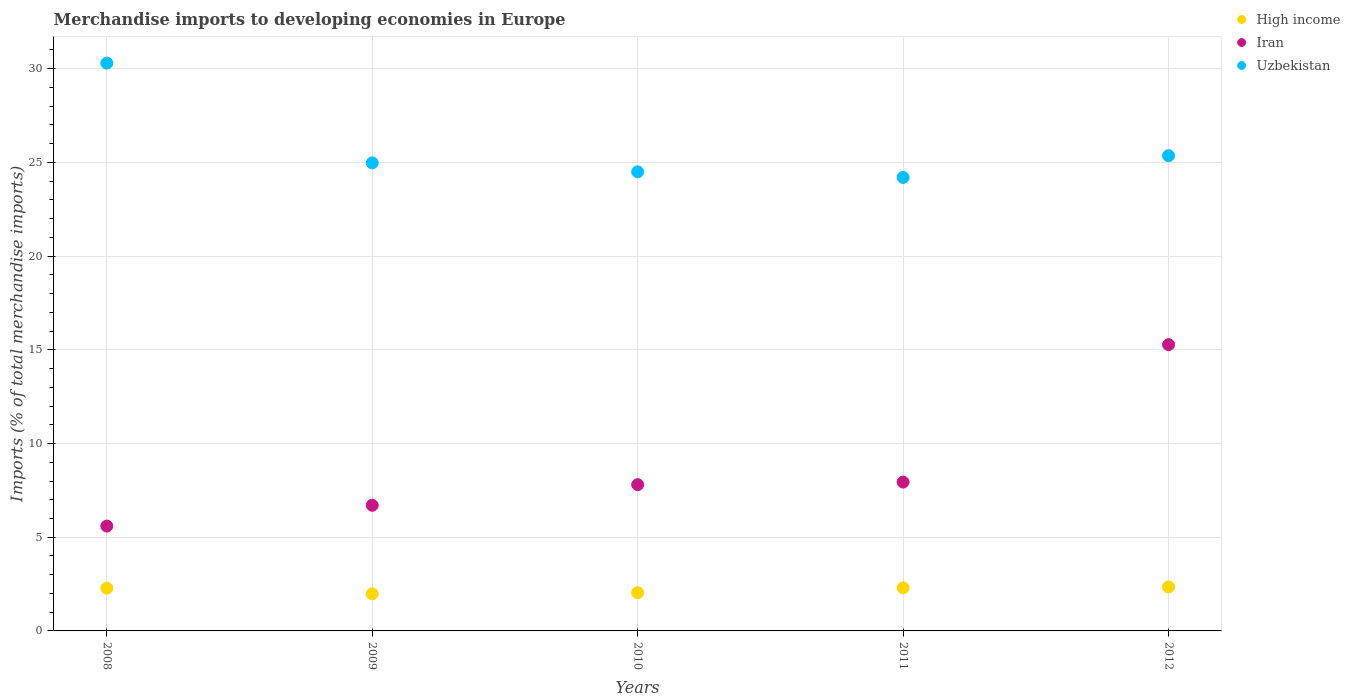How many different coloured dotlines are there?
Provide a short and direct response. 3. Is the number of dotlines equal to the number of legend labels?
Provide a succinct answer. Yes. What is the percentage total merchandise imports in Iran in 2008?
Provide a succinct answer. 5.6. Across all years, what is the maximum percentage total merchandise imports in Uzbekistan?
Provide a succinct answer. 30.3. Across all years, what is the minimum percentage total merchandise imports in Iran?
Provide a short and direct response. 5.6. In which year was the percentage total merchandise imports in Iran maximum?
Ensure brevity in your answer.  2012. What is the total percentage total merchandise imports in Iran in the graph?
Your response must be concise. 43.32. What is the difference between the percentage total merchandise imports in Iran in 2009 and that in 2010?
Ensure brevity in your answer.  -1.1. What is the difference between the percentage total merchandise imports in High income in 2012 and the percentage total merchandise imports in Uzbekistan in 2008?
Provide a short and direct response. -27.95. What is the average percentage total merchandise imports in Iran per year?
Your response must be concise. 8.66. In the year 2009, what is the difference between the percentage total merchandise imports in Iran and percentage total merchandise imports in High income?
Ensure brevity in your answer.  4.72. In how many years, is the percentage total merchandise imports in Iran greater than 8 %?
Keep it short and to the point. 1. What is the ratio of the percentage total merchandise imports in Uzbekistan in 2008 to that in 2010?
Make the answer very short. 1.24. Is the difference between the percentage total merchandise imports in Iran in 2008 and 2012 greater than the difference between the percentage total merchandise imports in High income in 2008 and 2012?
Your answer should be very brief. No. What is the difference between the highest and the second highest percentage total merchandise imports in Iran?
Your answer should be very brief. 7.33. What is the difference between the highest and the lowest percentage total merchandise imports in Uzbekistan?
Give a very brief answer. 6.1. In how many years, is the percentage total merchandise imports in Iran greater than the average percentage total merchandise imports in Iran taken over all years?
Offer a very short reply. 1. Is the percentage total merchandise imports in Uzbekistan strictly greater than the percentage total merchandise imports in Iran over the years?
Provide a short and direct response. Yes. Is the percentage total merchandise imports in Iran strictly less than the percentage total merchandise imports in High income over the years?
Make the answer very short. No. How many dotlines are there?
Provide a succinct answer. 3. How many years are there in the graph?
Give a very brief answer. 5. What is the difference between two consecutive major ticks on the Y-axis?
Your response must be concise. 5. What is the title of the graph?
Offer a terse response. Merchandise imports to developing economies in Europe. What is the label or title of the Y-axis?
Ensure brevity in your answer.  Imports (% of total merchandise imports). What is the Imports (% of total merchandise imports) in High income in 2008?
Offer a terse response. 2.28. What is the Imports (% of total merchandise imports) of Iran in 2008?
Keep it short and to the point. 5.6. What is the Imports (% of total merchandise imports) of Uzbekistan in 2008?
Offer a terse response. 30.3. What is the Imports (% of total merchandise imports) of High income in 2009?
Offer a very short reply. 1.98. What is the Imports (% of total merchandise imports) in Iran in 2009?
Offer a very short reply. 6.7. What is the Imports (% of total merchandise imports) of Uzbekistan in 2009?
Keep it short and to the point. 24.98. What is the Imports (% of total merchandise imports) of High income in 2010?
Your answer should be very brief. 2.04. What is the Imports (% of total merchandise imports) in Iran in 2010?
Offer a very short reply. 7.81. What is the Imports (% of total merchandise imports) in Uzbekistan in 2010?
Offer a very short reply. 24.5. What is the Imports (% of total merchandise imports) of High income in 2011?
Your answer should be compact. 2.3. What is the Imports (% of total merchandise imports) of Iran in 2011?
Give a very brief answer. 7.94. What is the Imports (% of total merchandise imports) in Uzbekistan in 2011?
Provide a succinct answer. 24.2. What is the Imports (% of total merchandise imports) in High income in 2012?
Your answer should be compact. 2.35. What is the Imports (% of total merchandise imports) in Iran in 2012?
Provide a succinct answer. 15.28. What is the Imports (% of total merchandise imports) of Uzbekistan in 2012?
Provide a short and direct response. 25.36. Across all years, what is the maximum Imports (% of total merchandise imports) in High income?
Provide a succinct answer. 2.35. Across all years, what is the maximum Imports (% of total merchandise imports) of Iran?
Offer a very short reply. 15.28. Across all years, what is the maximum Imports (% of total merchandise imports) of Uzbekistan?
Provide a succinct answer. 30.3. Across all years, what is the minimum Imports (% of total merchandise imports) of High income?
Make the answer very short. 1.98. Across all years, what is the minimum Imports (% of total merchandise imports) in Iran?
Provide a short and direct response. 5.6. Across all years, what is the minimum Imports (% of total merchandise imports) of Uzbekistan?
Ensure brevity in your answer.  24.2. What is the total Imports (% of total merchandise imports) of High income in the graph?
Keep it short and to the point. 10.95. What is the total Imports (% of total merchandise imports) in Iran in the graph?
Your answer should be very brief. 43.32. What is the total Imports (% of total merchandise imports) in Uzbekistan in the graph?
Your answer should be compact. 129.34. What is the difference between the Imports (% of total merchandise imports) of High income in 2008 and that in 2009?
Give a very brief answer. 0.3. What is the difference between the Imports (% of total merchandise imports) of Iran in 2008 and that in 2009?
Give a very brief answer. -1.11. What is the difference between the Imports (% of total merchandise imports) in Uzbekistan in 2008 and that in 2009?
Your answer should be very brief. 5.32. What is the difference between the Imports (% of total merchandise imports) of High income in 2008 and that in 2010?
Ensure brevity in your answer.  0.24. What is the difference between the Imports (% of total merchandise imports) in Iran in 2008 and that in 2010?
Offer a terse response. -2.21. What is the difference between the Imports (% of total merchandise imports) of Uzbekistan in 2008 and that in 2010?
Ensure brevity in your answer.  5.8. What is the difference between the Imports (% of total merchandise imports) of High income in 2008 and that in 2011?
Ensure brevity in your answer.  -0.02. What is the difference between the Imports (% of total merchandise imports) of Iran in 2008 and that in 2011?
Make the answer very short. -2.35. What is the difference between the Imports (% of total merchandise imports) of Uzbekistan in 2008 and that in 2011?
Your answer should be very brief. 6.1. What is the difference between the Imports (% of total merchandise imports) in High income in 2008 and that in 2012?
Offer a very short reply. -0.07. What is the difference between the Imports (% of total merchandise imports) of Iran in 2008 and that in 2012?
Give a very brief answer. -9.68. What is the difference between the Imports (% of total merchandise imports) of Uzbekistan in 2008 and that in 2012?
Offer a terse response. 4.94. What is the difference between the Imports (% of total merchandise imports) of High income in 2009 and that in 2010?
Provide a short and direct response. -0.06. What is the difference between the Imports (% of total merchandise imports) in Iran in 2009 and that in 2010?
Give a very brief answer. -1.1. What is the difference between the Imports (% of total merchandise imports) in Uzbekistan in 2009 and that in 2010?
Your answer should be compact. 0.48. What is the difference between the Imports (% of total merchandise imports) of High income in 2009 and that in 2011?
Your response must be concise. -0.32. What is the difference between the Imports (% of total merchandise imports) of Iran in 2009 and that in 2011?
Make the answer very short. -1.24. What is the difference between the Imports (% of total merchandise imports) of Uzbekistan in 2009 and that in 2011?
Your answer should be compact. 0.78. What is the difference between the Imports (% of total merchandise imports) of High income in 2009 and that in 2012?
Your answer should be compact. -0.37. What is the difference between the Imports (% of total merchandise imports) in Iran in 2009 and that in 2012?
Your response must be concise. -8.57. What is the difference between the Imports (% of total merchandise imports) of Uzbekistan in 2009 and that in 2012?
Your answer should be compact. -0.38. What is the difference between the Imports (% of total merchandise imports) in High income in 2010 and that in 2011?
Your answer should be very brief. -0.26. What is the difference between the Imports (% of total merchandise imports) of Iran in 2010 and that in 2011?
Keep it short and to the point. -0.14. What is the difference between the Imports (% of total merchandise imports) in Uzbekistan in 2010 and that in 2011?
Offer a very short reply. 0.3. What is the difference between the Imports (% of total merchandise imports) of High income in 2010 and that in 2012?
Your answer should be compact. -0.31. What is the difference between the Imports (% of total merchandise imports) of Iran in 2010 and that in 2012?
Offer a terse response. -7.47. What is the difference between the Imports (% of total merchandise imports) of Uzbekistan in 2010 and that in 2012?
Give a very brief answer. -0.86. What is the difference between the Imports (% of total merchandise imports) in High income in 2011 and that in 2012?
Offer a terse response. -0.05. What is the difference between the Imports (% of total merchandise imports) of Iran in 2011 and that in 2012?
Give a very brief answer. -7.33. What is the difference between the Imports (% of total merchandise imports) in Uzbekistan in 2011 and that in 2012?
Keep it short and to the point. -1.16. What is the difference between the Imports (% of total merchandise imports) of High income in 2008 and the Imports (% of total merchandise imports) of Iran in 2009?
Ensure brevity in your answer.  -4.42. What is the difference between the Imports (% of total merchandise imports) of High income in 2008 and the Imports (% of total merchandise imports) of Uzbekistan in 2009?
Provide a short and direct response. -22.7. What is the difference between the Imports (% of total merchandise imports) of Iran in 2008 and the Imports (% of total merchandise imports) of Uzbekistan in 2009?
Ensure brevity in your answer.  -19.38. What is the difference between the Imports (% of total merchandise imports) in High income in 2008 and the Imports (% of total merchandise imports) in Iran in 2010?
Your response must be concise. -5.52. What is the difference between the Imports (% of total merchandise imports) in High income in 2008 and the Imports (% of total merchandise imports) in Uzbekistan in 2010?
Your answer should be very brief. -22.22. What is the difference between the Imports (% of total merchandise imports) of Iran in 2008 and the Imports (% of total merchandise imports) of Uzbekistan in 2010?
Ensure brevity in your answer.  -18.9. What is the difference between the Imports (% of total merchandise imports) in High income in 2008 and the Imports (% of total merchandise imports) in Iran in 2011?
Your answer should be compact. -5.66. What is the difference between the Imports (% of total merchandise imports) of High income in 2008 and the Imports (% of total merchandise imports) of Uzbekistan in 2011?
Make the answer very short. -21.92. What is the difference between the Imports (% of total merchandise imports) of Iran in 2008 and the Imports (% of total merchandise imports) of Uzbekistan in 2011?
Ensure brevity in your answer.  -18.6. What is the difference between the Imports (% of total merchandise imports) of High income in 2008 and the Imports (% of total merchandise imports) of Iran in 2012?
Give a very brief answer. -12.99. What is the difference between the Imports (% of total merchandise imports) of High income in 2008 and the Imports (% of total merchandise imports) of Uzbekistan in 2012?
Give a very brief answer. -23.08. What is the difference between the Imports (% of total merchandise imports) in Iran in 2008 and the Imports (% of total merchandise imports) in Uzbekistan in 2012?
Provide a succinct answer. -19.77. What is the difference between the Imports (% of total merchandise imports) in High income in 2009 and the Imports (% of total merchandise imports) in Iran in 2010?
Ensure brevity in your answer.  -5.82. What is the difference between the Imports (% of total merchandise imports) of High income in 2009 and the Imports (% of total merchandise imports) of Uzbekistan in 2010?
Your answer should be compact. -22.52. What is the difference between the Imports (% of total merchandise imports) in Iran in 2009 and the Imports (% of total merchandise imports) in Uzbekistan in 2010?
Give a very brief answer. -17.79. What is the difference between the Imports (% of total merchandise imports) of High income in 2009 and the Imports (% of total merchandise imports) of Iran in 2011?
Give a very brief answer. -5.96. What is the difference between the Imports (% of total merchandise imports) of High income in 2009 and the Imports (% of total merchandise imports) of Uzbekistan in 2011?
Your answer should be very brief. -22.22. What is the difference between the Imports (% of total merchandise imports) of Iran in 2009 and the Imports (% of total merchandise imports) of Uzbekistan in 2011?
Keep it short and to the point. -17.5. What is the difference between the Imports (% of total merchandise imports) in High income in 2009 and the Imports (% of total merchandise imports) in Iran in 2012?
Offer a very short reply. -13.3. What is the difference between the Imports (% of total merchandise imports) in High income in 2009 and the Imports (% of total merchandise imports) in Uzbekistan in 2012?
Your response must be concise. -23.38. What is the difference between the Imports (% of total merchandise imports) of Iran in 2009 and the Imports (% of total merchandise imports) of Uzbekistan in 2012?
Offer a very short reply. -18.66. What is the difference between the Imports (% of total merchandise imports) in High income in 2010 and the Imports (% of total merchandise imports) in Iran in 2011?
Your response must be concise. -5.9. What is the difference between the Imports (% of total merchandise imports) in High income in 2010 and the Imports (% of total merchandise imports) in Uzbekistan in 2011?
Your response must be concise. -22.16. What is the difference between the Imports (% of total merchandise imports) of Iran in 2010 and the Imports (% of total merchandise imports) of Uzbekistan in 2011?
Your answer should be compact. -16.39. What is the difference between the Imports (% of total merchandise imports) of High income in 2010 and the Imports (% of total merchandise imports) of Iran in 2012?
Give a very brief answer. -13.24. What is the difference between the Imports (% of total merchandise imports) in High income in 2010 and the Imports (% of total merchandise imports) in Uzbekistan in 2012?
Your answer should be compact. -23.32. What is the difference between the Imports (% of total merchandise imports) of Iran in 2010 and the Imports (% of total merchandise imports) of Uzbekistan in 2012?
Give a very brief answer. -17.55. What is the difference between the Imports (% of total merchandise imports) in High income in 2011 and the Imports (% of total merchandise imports) in Iran in 2012?
Ensure brevity in your answer.  -12.98. What is the difference between the Imports (% of total merchandise imports) in High income in 2011 and the Imports (% of total merchandise imports) in Uzbekistan in 2012?
Your response must be concise. -23.06. What is the difference between the Imports (% of total merchandise imports) of Iran in 2011 and the Imports (% of total merchandise imports) of Uzbekistan in 2012?
Your answer should be very brief. -17.42. What is the average Imports (% of total merchandise imports) in High income per year?
Your answer should be very brief. 2.19. What is the average Imports (% of total merchandise imports) of Iran per year?
Provide a short and direct response. 8.66. What is the average Imports (% of total merchandise imports) of Uzbekistan per year?
Keep it short and to the point. 25.87. In the year 2008, what is the difference between the Imports (% of total merchandise imports) of High income and Imports (% of total merchandise imports) of Iran?
Provide a short and direct response. -3.31. In the year 2008, what is the difference between the Imports (% of total merchandise imports) in High income and Imports (% of total merchandise imports) in Uzbekistan?
Your answer should be compact. -28.02. In the year 2008, what is the difference between the Imports (% of total merchandise imports) of Iran and Imports (% of total merchandise imports) of Uzbekistan?
Make the answer very short. -24.7. In the year 2009, what is the difference between the Imports (% of total merchandise imports) of High income and Imports (% of total merchandise imports) of Iran?
Offer a terse response. -4.72. In the year 2009, what is the difference between the Imports (% of total merchandise imports) of High income and Imports (% of total merchandise imports) of Uzbekistan?
Make the answer very short. -23. In the year 2009, what is the difference between the Imports (% of total merchandise imports) in Iran and Imports (% of total merchandise imports) in Uzbekistan?
Provide a short and direct response. -18.27. In the year 2010, what is the difference between the Imports (% of total merchandise imports) of High income and Imports (% of total merchandise imports) of Iran?
Provide a succinct answer. -5.77. In the year 2010, what is the difference between the Imports (% of total merchandise imports) in High income and Imports (% of total merchandise imports) in Uzbekistan?
Provide a short and direct response. -22.46. In the year 2010, what is the difference between the Imports (% of total merchandise imports) in Iran and Imports (% of total merchandise imports) in Uzbekistan?
Ensure brevity in your answer.  -16.69. In the year 2011, what is the difference between the Imports (% of total merchandise imports) in High income and Imports (% of total merchandise imports) in Iran?
Give a very brief answer. -5.64. In the year 2011, what is the difference between the Imports (% of total merchandise imports) in High income and Imports (% of total merchandise imports) in Uzbekistan?
Offer a very short reply. -21.9. In the year 2011, what is the difference between the Imports (% of total merchandise imports) of Iran and Imports (% of total merchandise imports) of Uzbekistan?
Offer a terse response. -16.26. In the year 2012, what is the difference between the Imports (% of total merchandise imports) of High income and Imports (% of total merchandise imports) of Iran?
Offer a very short reply. -12.93. In the year 2012, what is the difference between the Imports (% of total merchandise imports) of High income and Imports (% of total merchandise imports) of Uzbekistan?
Make the answer very short. -23.01. In the year 2012, what is the difference between the Imports (% of total merchandise imports) of Iran and Imports (% of total merchandise imports) of Uzbekistan?
Give a very brief answer. -10.08. What is the ratio of the Imports (% of total merchandise imports) in High income in 2008 to that in 2009?
Give a very brief answer. 1.15. What is the ratio of the Imports (% of total merchandise imports) in Iran in 2008 to that in 2009?
Your answer should be very brief. 0.83. What is the ratio of the Imports (% of total merchandise imports) of Uzbekistan in 2008 to that in 2009?
Offer a terse response. 1.21. What is the ratio of the Imports (% of total merchandise imports) in High income in 2008 to that in 2010?
Your answer should be very brief. 1.12. What is the ratio of the Imports (% of total merchandise imports) of Iran in 2008 to that in 2010?
Offer a terse response. 0.72. What is the ratio of the Imports (% of total merchandise imports) of Uzbekistan in 2008 to that in 2010?
Keep it short and to the point. 1.24. What is the ratio of the Imports (% of total merchandise imports) of Iran in 2008 to that in 2011?
Provide a short and direct response. 0.7. What is the ratio of the Imports (% of total merchandise imports) in Uzbekistan in 2008 to that in 2011?
Your answer should be very brief. 1.25. What is the ratio of the Imports (% of total merchandise imports) in High income in 2008 to that in 2012?
Your answer should be very brief. 0.97. What is the ratio of the Imports (% of total merchandise imports) in Iran in 2008 to that in 2012?
Provide a short and direct response. 0.37. What is the ratio of the Imports (% of total merchandise imports) in Uzbekistan in 2008 to that in 2012?
Provide a succinct answer. 1.19. What is the ratio of the Imports (% of total merchandise imports) of High income in 2009 to that in 2010?
Offer a very short reply. 0.97. What is the ratio of the Imports (% of total merchandise imports) in Iran in 2009 to that in 2010?
Your answer should be compact. 0.86. What is the ratio of the Imports (% of total merchandise imports) in Uzbekistan in 2009 to that in 2010?
Ensure brevity in your answer.  1.02. What is the ratio of the Imports (% of total merchandise imports) of High income in 2009 to that in 2011?
Give a very brief answer. 0.86. What is the ratio of the Imports (% of total merchandise imports) in Iran in 2009 to that in 2011?
Give a very brief answer. 0.84. What is the ratio of the Imports (% of total merchandise imports) of Uzbekistan in 2009 to that in 2011?
Make the answer very short. 1.03. What is the ratio of the Imports (% of total merchandise imports) in High income in 2009 to that in 2012?
Your answer should be very brief. 0.84. What is the ratio of the Imports (% of total merchandise imports) of Iran in 2009 to that in 2012?
Give a very brief answer. 0.44. What is the ratio of the Imports (% of total merchandise imports) of Uzbekistan in 2009 to that in 2012?
Offer a very short reply. 0.98. What is the ratio of the Imports (% of total merchandise imports) in High income in 2010 to that in 2011?
Provide a short and direct response. 0.89. What is the ratio of the Imports (% of total merchandise imports) in Iran in 2010 to that in 2011?
Your answer should be compact. 0.98. What is the ratio of the Imports (% of total merchandise imports) of Uzbekistan in 2010 to that in 2011?
Your response must be concise. 1.01. What is the ratio of the Imports (% of total merchandise imports) in High income in 2010 to that in 2012?
Keep it short and to the point. 0.87. What is the ratio of the Imports (% of total merchandise imports) in Iran in 2010 to that in 2012?
Your response must be concise. 0.51. What is the ratio of the Imports (% of total merchandise imports) in Uzbekistan in 2010 to that in 2012?
Offer a terse response. 0.97. What is the ratio of the Imports (% of total merchandise imports) of High income in 2011 to that in 2012?
Offer a terse response. 0.98. What is the ratio of the Imports (% of total merchandise imports) of Iran in 2011 to that in 2012?
Your answer should be very brief. 0.52. What is the ratio of the Imports (% of total merchandise imports) in Uzbekistan in 2011 to that in 2012?
Offer a very short reply. 0.95. What is the difference between the highest and the second highest Imports (% of total merchandise imports) of High income?
Your answer should be compact. 0.05. What is the difference between the highest and the second highest Imports (% of total merchandise imports) in Iran?
Your response must be concise. 7.33. What is the difference between the highest and the second highest Imports (% of total merchandise imports) of Uzbekistan?
Give a very brief answer. 4.94. What is the difference between the highest and the lowest Imports (% of total merchandise imports) of High income?
Ensure brevity in your answer.  0.37. What is the difference between the highest and the lowest Imports (% of total merchandise imports) in Iran?
Your answer should be compact. 9.68. What is the difference between the highest and the lowest Imports (% of total merchandise imports) of Uzbekistan?
Make the answer very short. 6.1. 